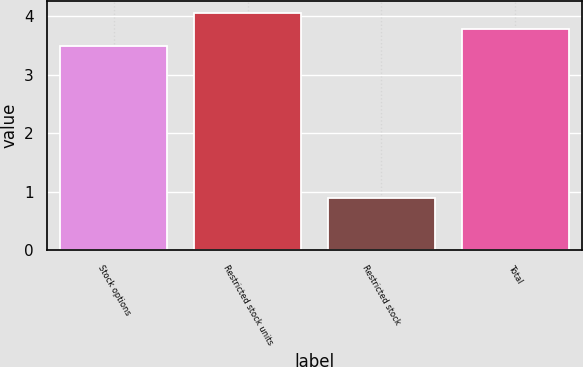Convert chart to OTSL. <chart><loc_0><loc_0><loc_500><loc_500><bar_chart><fcel>Stock options<fcel>Restricted stock units<fcel>Restricted stock<fcel>Total<nl><fcel>3.5<fcel>4.06<fcel>0.9<fcel>3.78<nl></chart> 